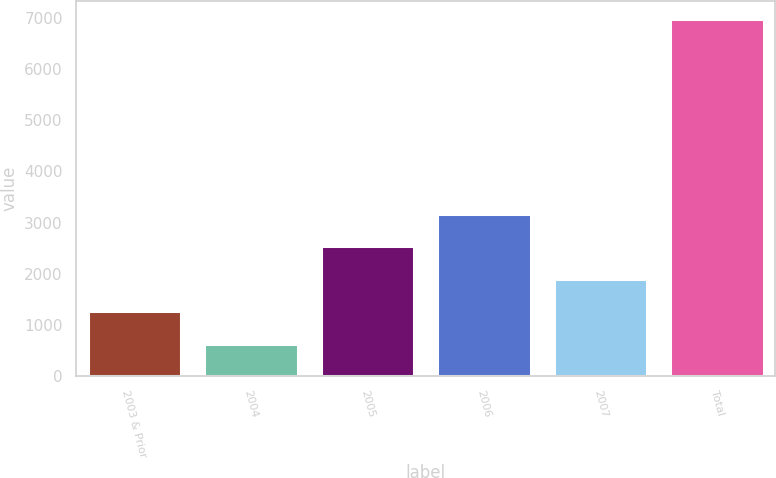Convert chart. <chart><loc_0><loc_0><loc_500><loc_500><bar_chart><fcel>2003 & Prior<fcel>2004<fcel>2005<fcel>2006<fcel>2007<fcel>Total<nl><fcel>1266.4<fcel>631<fcel>2537.2<fcel>3172.6<fcel>1901.8<fcel>6985<nl></chart> 